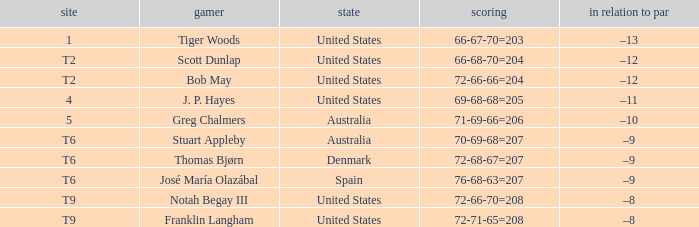What is the place of the player with a 72-71-65=208 score? T9. 